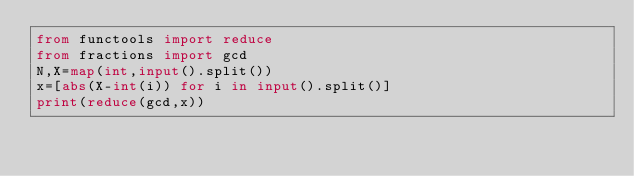Convert code to text. <code><loc_0><loc_0><loc_500><loc_500><_Python_>from functools import reduce
from fractions import gcd
N,X=map(int,input().split())
x=[abs(X-int(i)) for i in input().split()]
print(reduce(gcd,x))</code> 